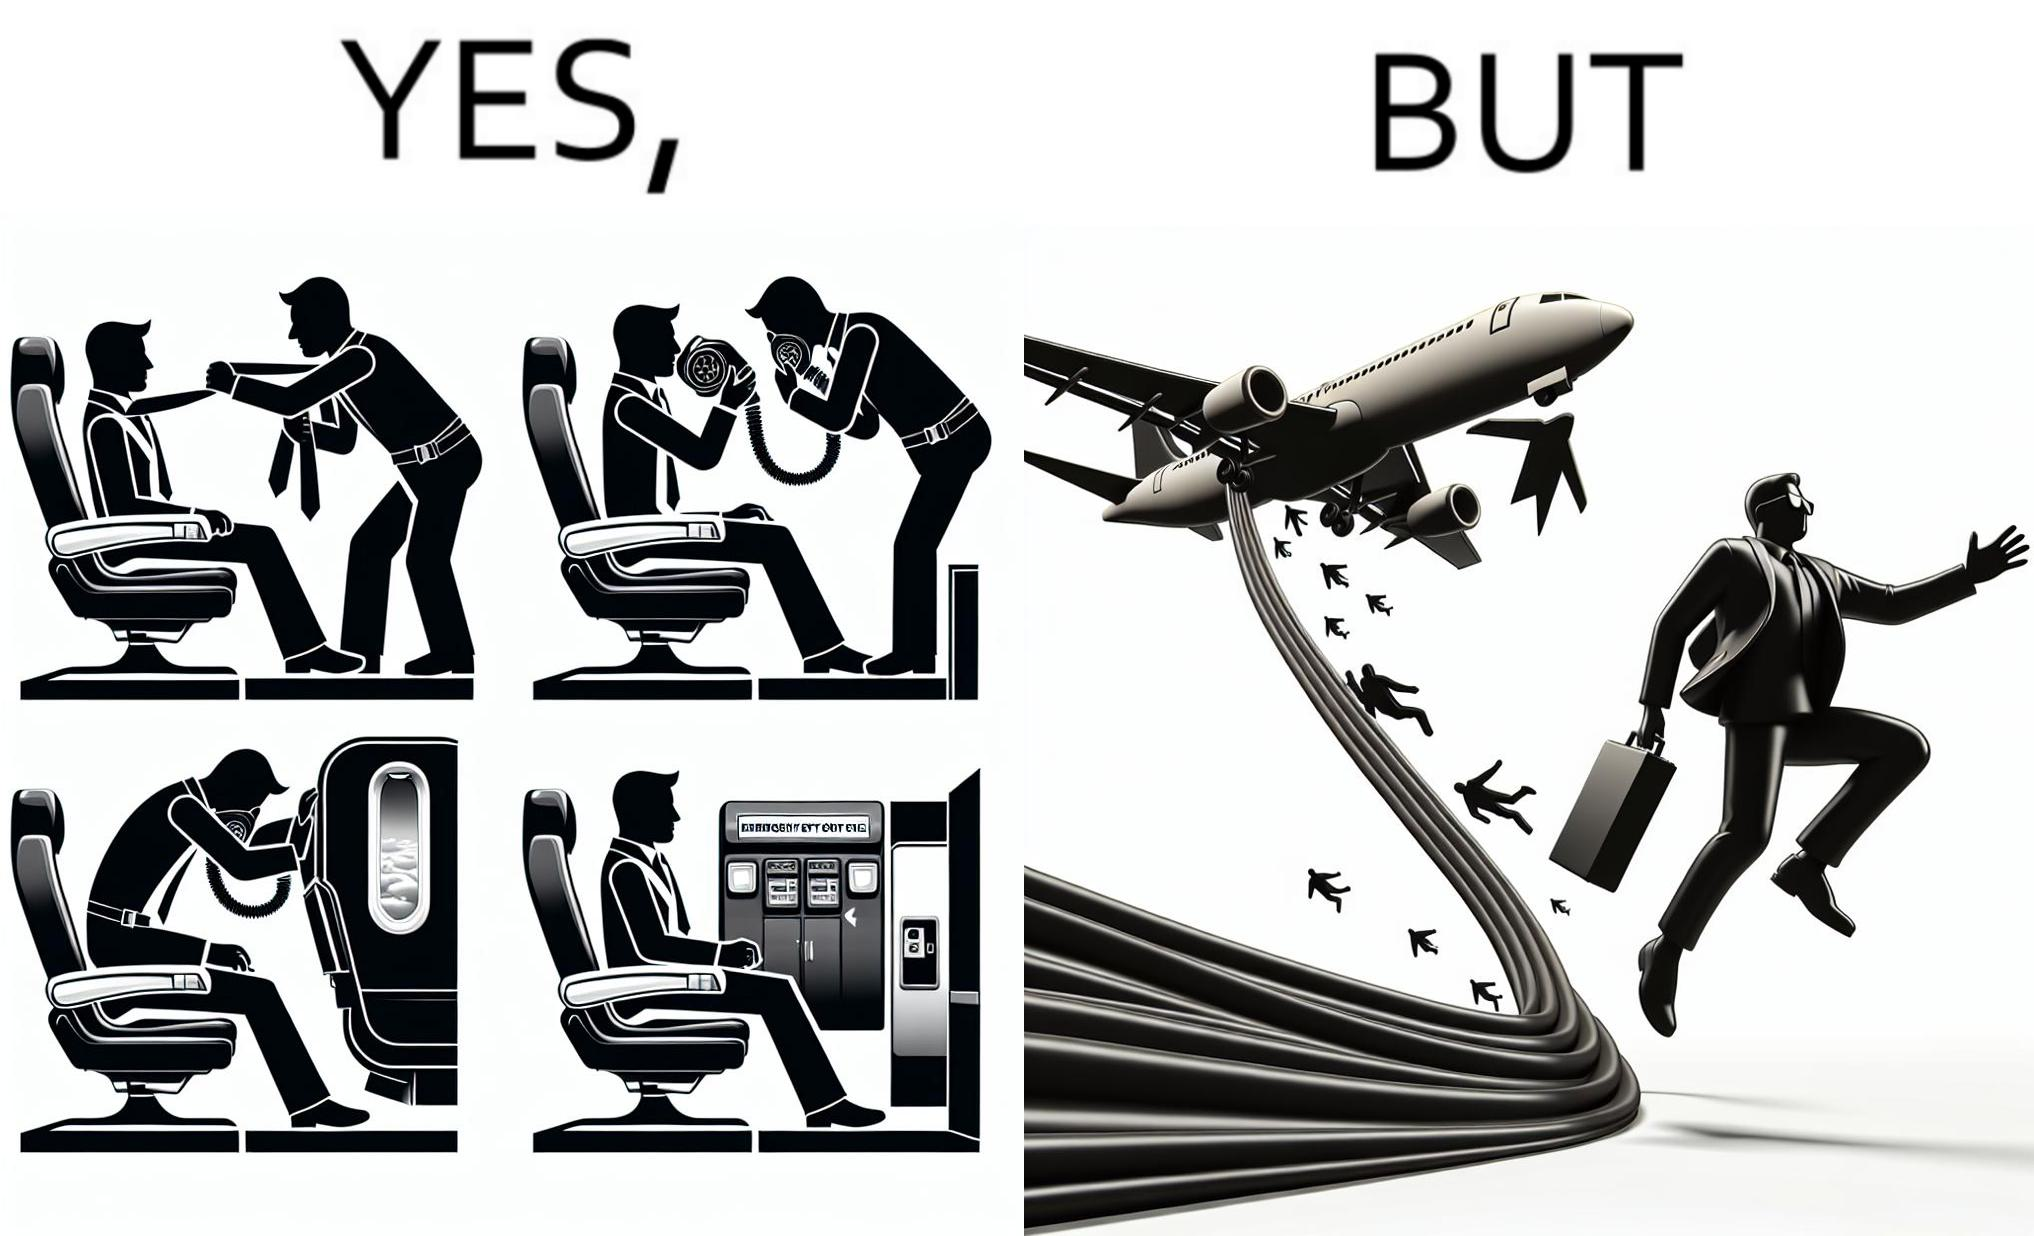What is shown in the left half versus the right half of this image? In the left part of the image: They are images of what one should do in an airplane in case of an imminent collision and fire In the right part of the image: It shows a man jumping out of an airplane in case of an emergency and using the emergency inflatable slides 